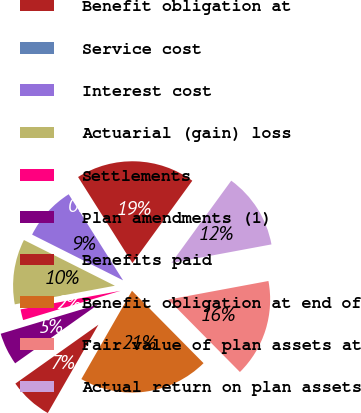Convert chart to OTSL. <chart><loc_0><loc_0><loc_500><loc_500><pie_chart><fcel>Benefit obligation at<fcel>Service cost<fcel>Interest cost<fcel>Actuarial (gain) loss<fcel>Settlements<fcel>Plan amendments (1)<fcel>Benefits paid<fcel>Benefit obligation at end of<fcel>Fair value of plan assets at<fcel>Actual return on plan assets<nl><fcel>18.97%<fcel>0.0%<fcel>8.62%<fcel>10.34%<fcel>1.72%<fcel>5.17%<fcel>6.9%<fcel>20.69%<fcel>15.52%<fcel>12.07%<nl></chart> 